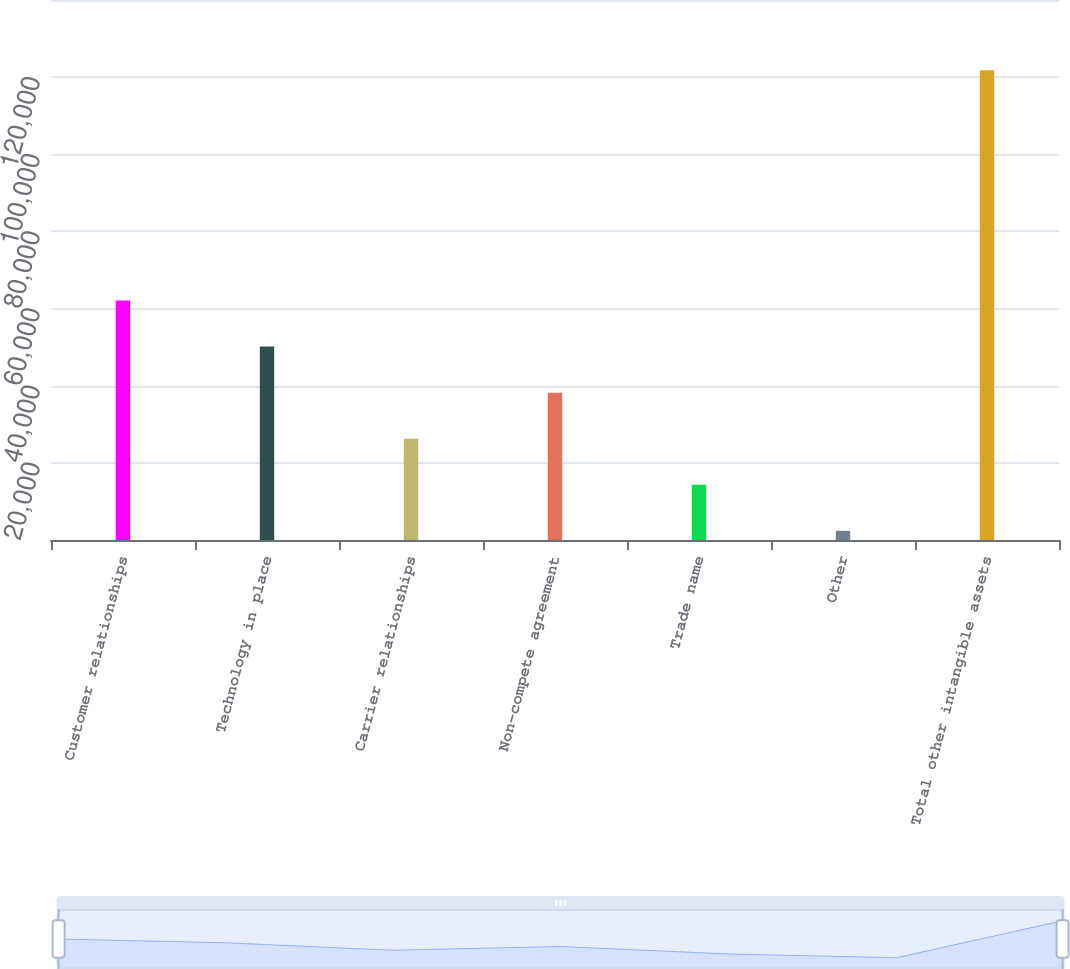Convert chart. <chart><loc_0><loc_0><loc_500><loc_500><bar_chart><fcel>Customer relationships<fcel>Technology in place<fcel>Carrier relationships<fcel>Non-compete agreement<fcel>Trade name<fcel>Other<fcel>Total other intangible assets<nl><fcel>62086.5<fcel>50145.4<fcel>26263.2<fcel>38204.3<fcel>14322.1<fcel>2381<fcel>121792<nl></chart> 